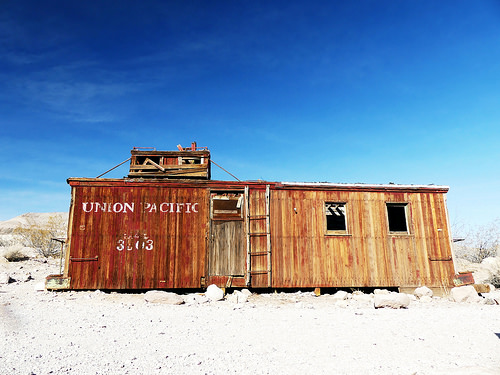<image>
Can you confirm if the ladder is under the sky? Yes. The ladder is positioned underneath the sky, with the sky above it in the vertical space. Where is the house in relation to the ground? Is it behind the ground? No. The house is not behind the ground. From this viewpoint, the house appears to be positioned elsewhere in the scene. 